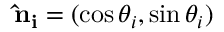<formula> <loc_0><loc_0><loc_500><loc_500>\hat { n } _ { i } = ( \cos \theta _ { i } , \sin \theta _ { i } )</formula> 